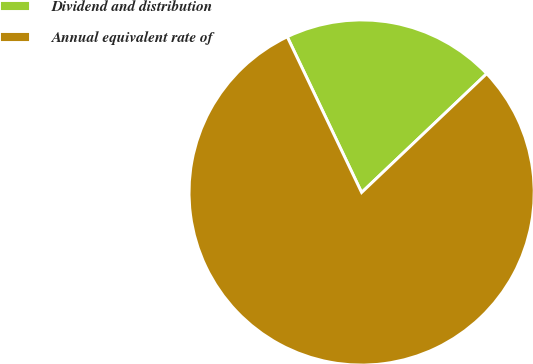Convert chart. <chart><loc_0><loc_0><loc_500><loc_500><pie_chart><fcel>Dividend and distribution<fcel>Annual equivalent rate of<nl><fcel>20.0%<fcel>80.0%<nl></chart> 